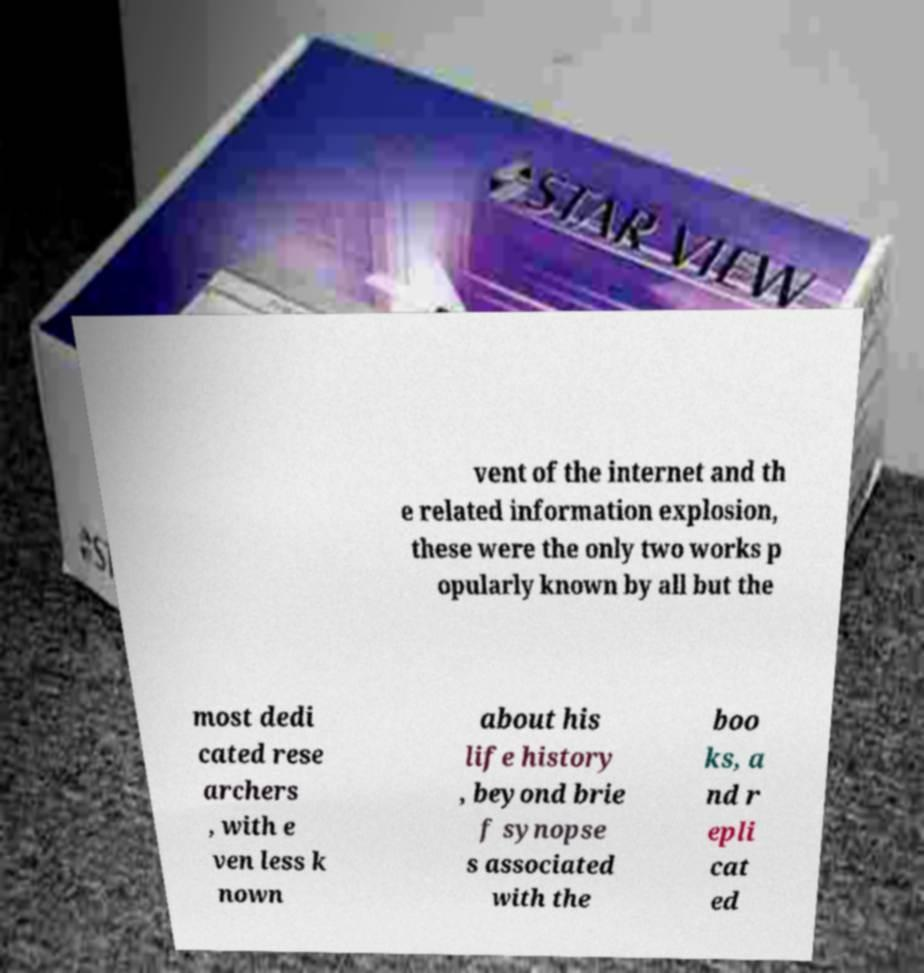There's text embedded in this image that I need extracted. Can you transcribe it verbatim? vent of the internet and th e related information explosion, these were the only two works p opularly known by all but the most dedi cated rese archers , with e ven less k nown about his life history , beyond brie f synopse s associated with the boo ks, a nd r epli cat ed 